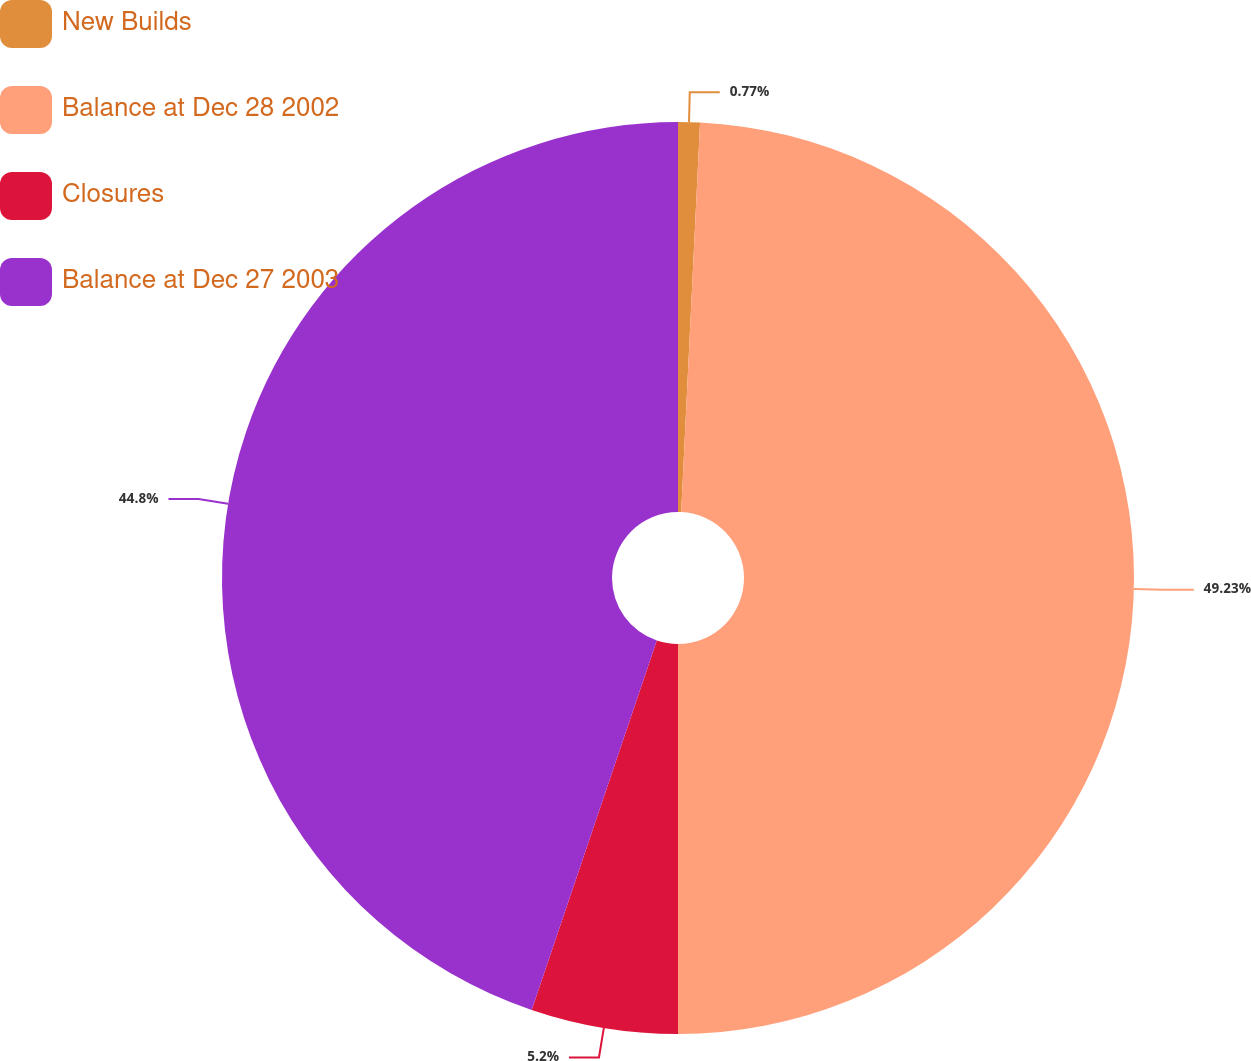Convert chart. <chart><loc_0><loc_0><loc_500><loc_500><pie_chart><fcel>New Builds<fcel>Balance at Dec 28 2002<fcel>Closures<fcel>Balance at Dec 27 2003<nl><fcel>0.77%<fcel>49.23%<fcel>5.2%<fcel>44.8%<nl></chart> 